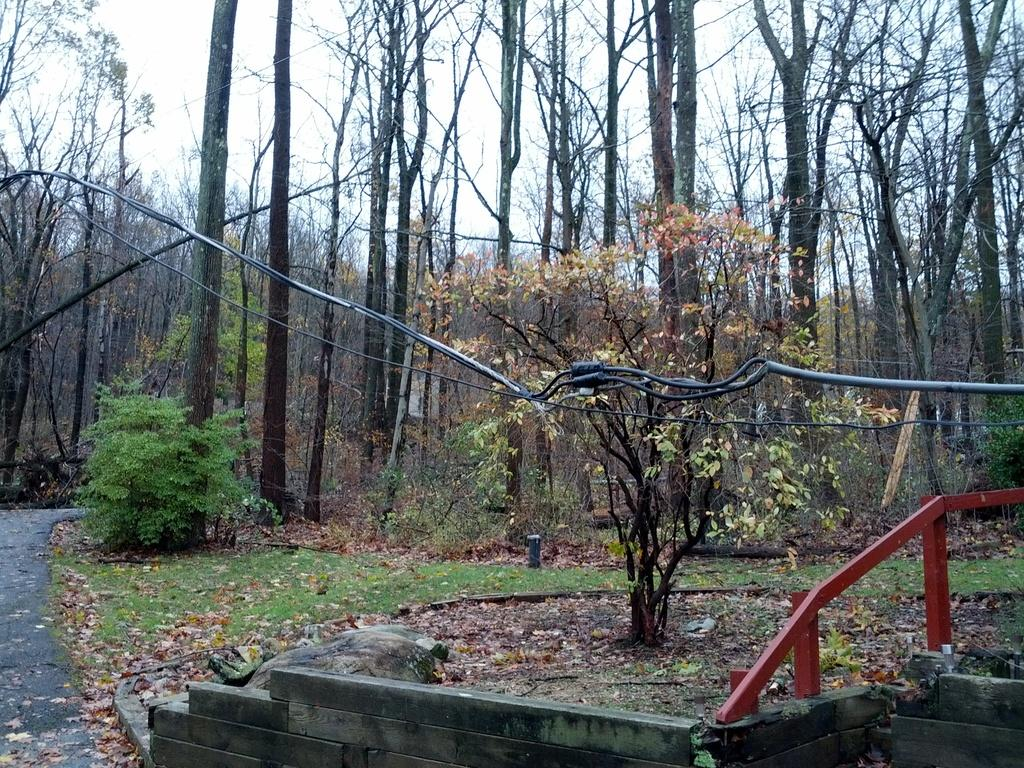What type of vegetation can be seen in the image? There are trees in the image. What else is present in the image besides trees? There are wires and a red color railing in the image. What type of structure can be seen in the image? There is a wall in the image. What is the rate of the business in the image? There is no business present in the image, so it is not possible to determine the rate. 